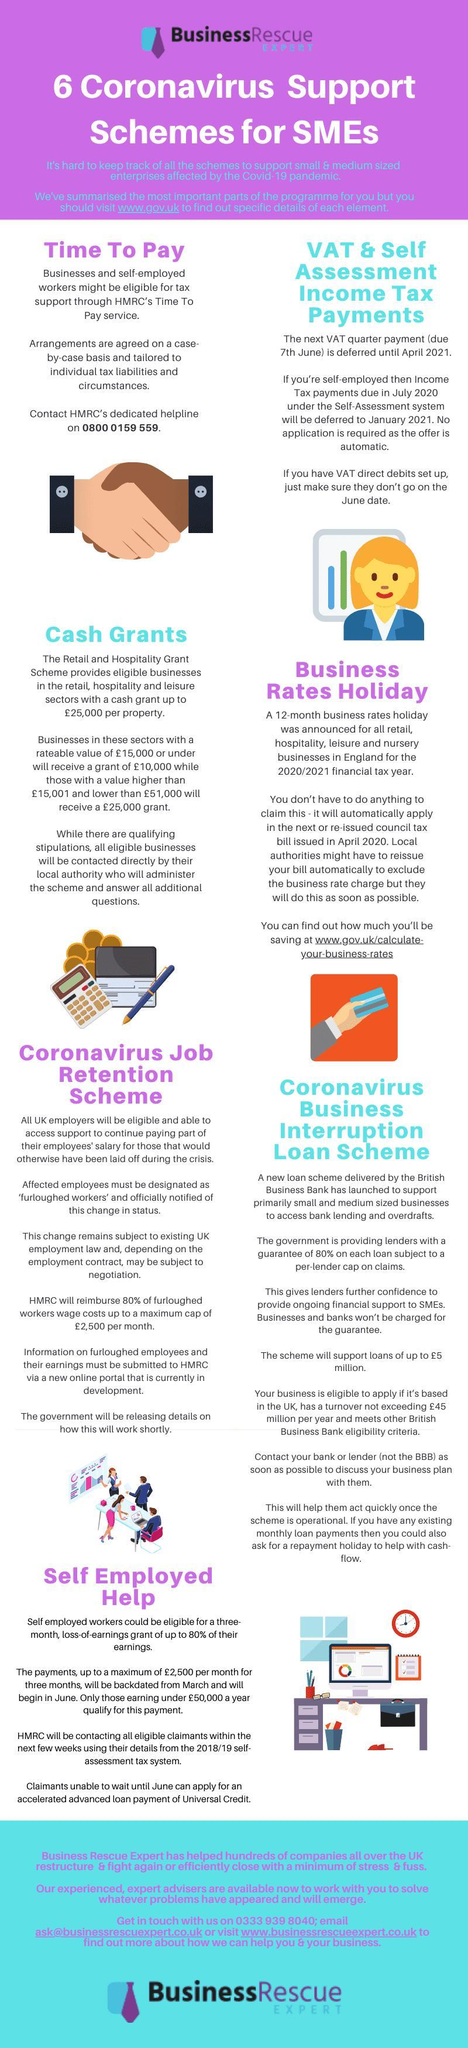When is the new date for VAT quarter payment for those who are not self-employed?
Answer the question with a short phrase. April 2021 